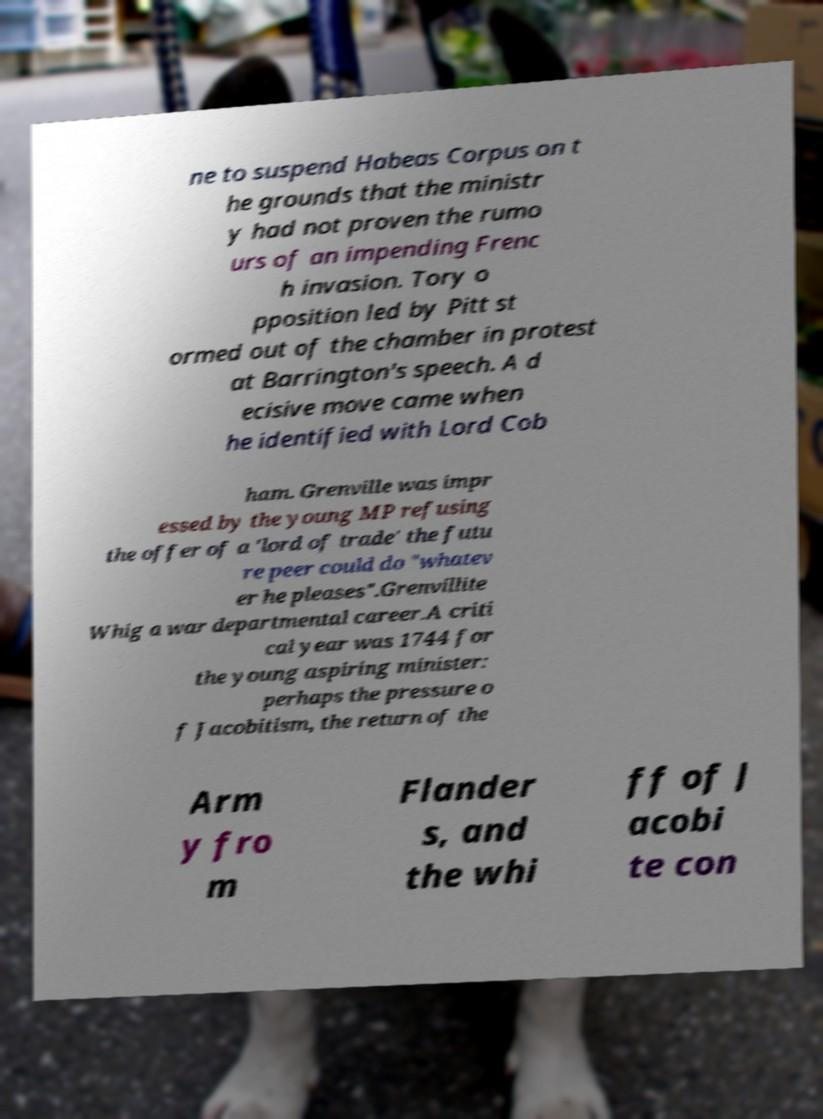There's text embedded in this image that I need extracted. Can you transcribe it verbatim? ne to suspend Habeas Corpus on t he grounds that the ministr y had not proven the rumo urs of an impending Frenc h invasion. Tory o pposition led by Pitt st ormed out of the chamber in protest at Barrington's speech. A d ecisive move came when he identified with Lord Cob ham. Grenville was impr essed by the young MP refusing the offer of a 'lord of trade' the futu re peer could do "whatev er he pleases".Grenvillite Whig a war departmental career.A criti cal year was 1744 for the young aspiring minister: perhaps the pressure o f Jacobitism, the return of the Arm y fro m Flander s, and the whi ff of J acobi te con 